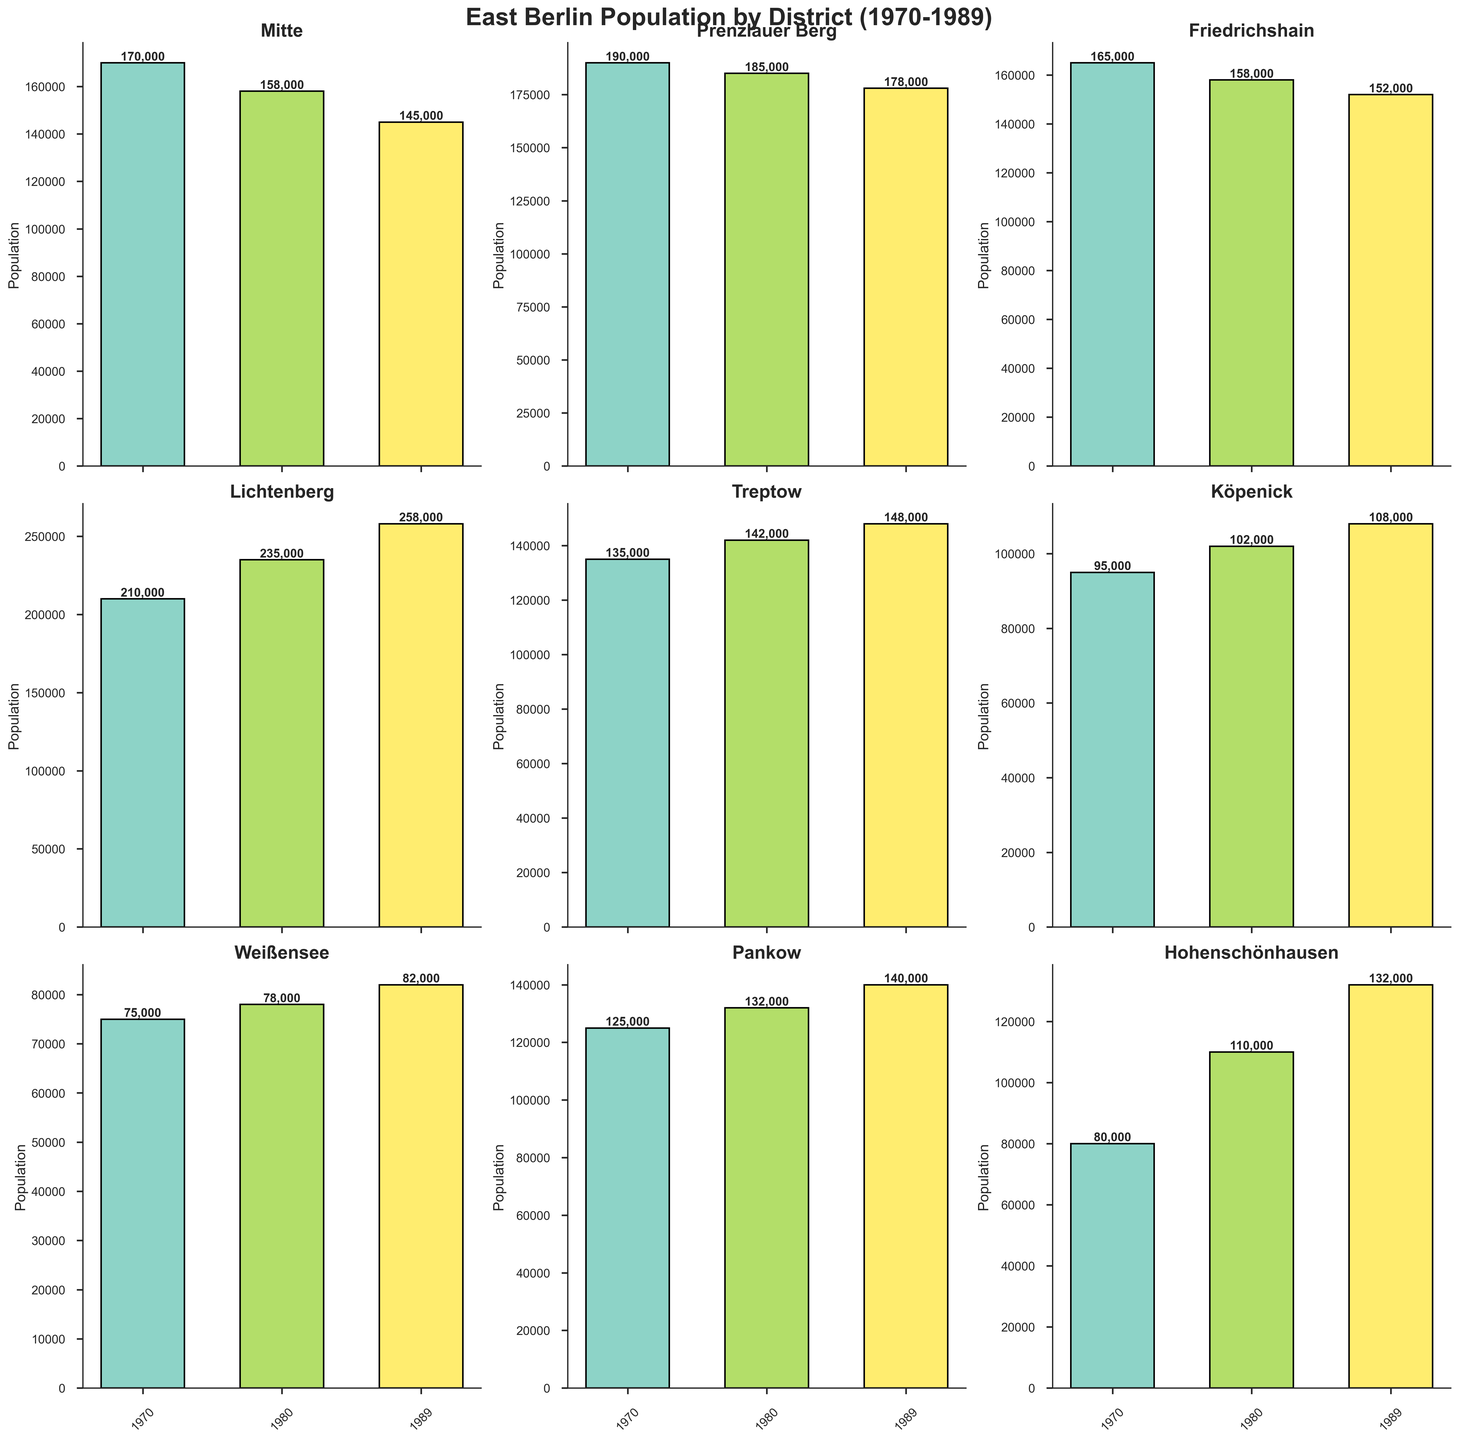Which district had the highest population in 1980? Look at the subplot for each district and observe the 1980 bars. The tallest bar for 1980 is in Lichtenberg.
Answer: Lichtenberg Which district shows a continuous decrease in population from 1970 to 1989? Examine the trend of the bars for each district across the years. Mitte exhibits a continuous decrease.
Answer: Mitte Which district had the smallest population in 1970? Identify the shortest bar in the 1970 category. This belongs to Weißensee.
Answer: Weißensee By how much did the population of Hohenschönhausen increase from 1970 to 1989? Subtract the population of Hohenschönhausen in 1970 (80,000) from its population in 1989 (132,000). 132,000 - 80,000 = 52,000
Answer: 52,000 Which district had the most significant population growth between 1970 and 1989? Calculate the difference in population for each district between 1970 and 1989. Lichtenberg has the highest growth of 48,000.
Answer: Lichtenberg How did the total population of Prenzlauer Berg and Friedrichshain combined change from 1970 to 1989? Add the populations of both districts for 1970 and 1989, then find the difference. (190,000 + 165,000) for 1970 and (178,000 + 152,000) for 1989. Total change is (178,000 + 152,000) - (190,000 + 165,000) = -25,000
Answer: -25,000 Which districts had a higher population in 1989 than 1970? Compare the bars for 1970 and 1989 for each district. Lichtenberg, Treptow, Köpenick, Weißensee, Pankow, and Hohenschönhausen all had higher populations in 1989.
Answer: Lichtenberg, Treptow, Köpenick, Weißensee, Pankow, Hohenschönhausen Rank the districts by population in 1970 from highest to lowest. Look at the height of each bar in the 1970 category: Lichtenberg, Prenzlauer Berg, Mitte, Friedrichshain, Pankow, Treptow, Hohenschönhausen, Köpenick, Weißensee.
Answer: Lichtenberg, Prenzlauer Berg, Mitte, Friedrichshain, Pankow, Treptow, Hohenschönhausen, Köpenick, Weißensee Which district had a population closest to 100,000 in 1989? Identify the 1989 bars and find the one nearest to 100,000. Köpenick had a population of 108,000.
Answer: Köpenick 